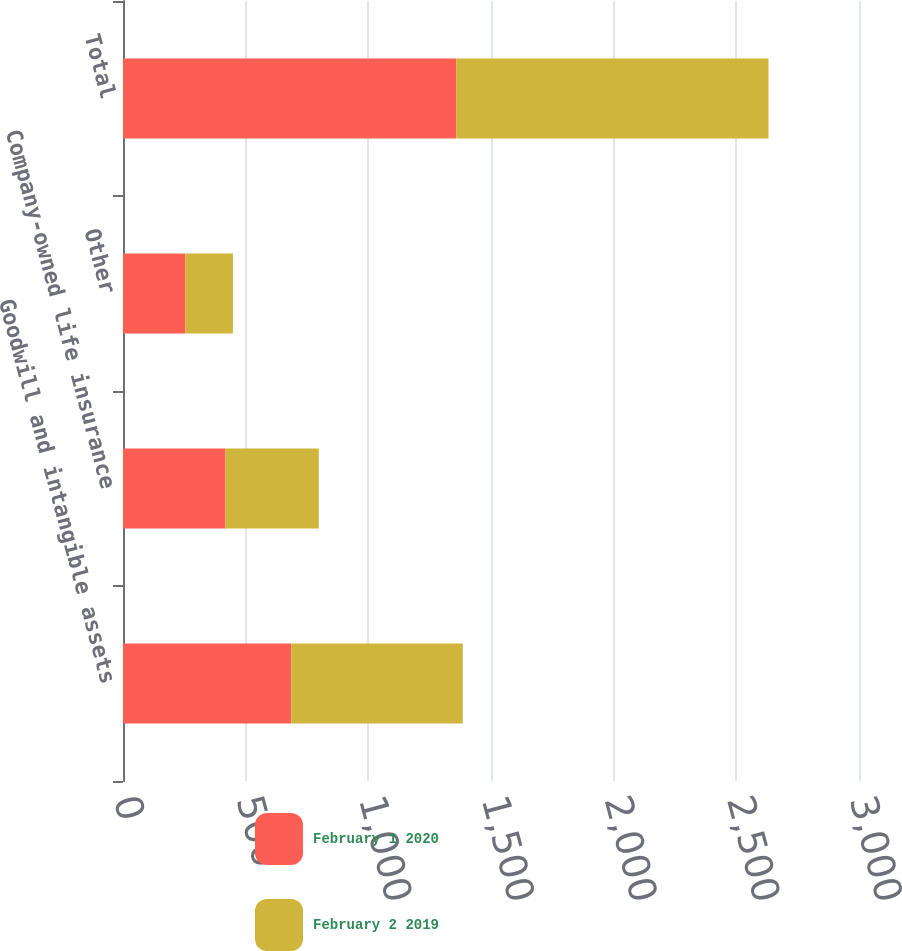Convert chart to OTSL. <chart><loc_0><loc_0><loc_500><loc_500><stacked_bar_chart><ecel><fcel>Goodwill and intangible assets<fcel>Company-owned life insurance<fcel>Other<fcel>Total<nl><fcel>February 1 2020<fcel>686<fcel>418<fcel>254<fcel>1358<nl><fcel>February 2 2019<fcel>699<fcel>380<fcel>194<fcel>1273<nl></chart> 